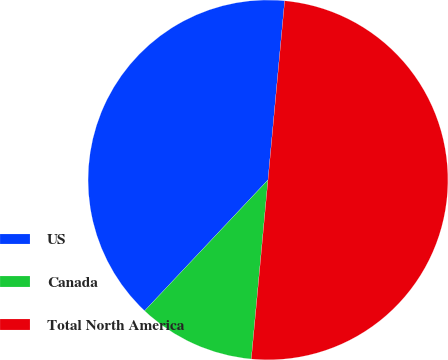Convert chart. <chart><loc_0><loc_0><loc_500><loc_500><pie_chart><fcel>US<fcel>Canada<fcel>Total North America<nl><fcel>39.45%<fcel>10.55%<fcel>50.0%<nl></chart> 